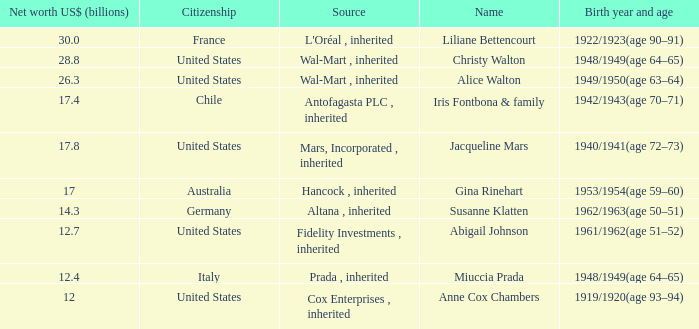What's the source of wealth of the person worth $17 billion? Hancock , inherited. 